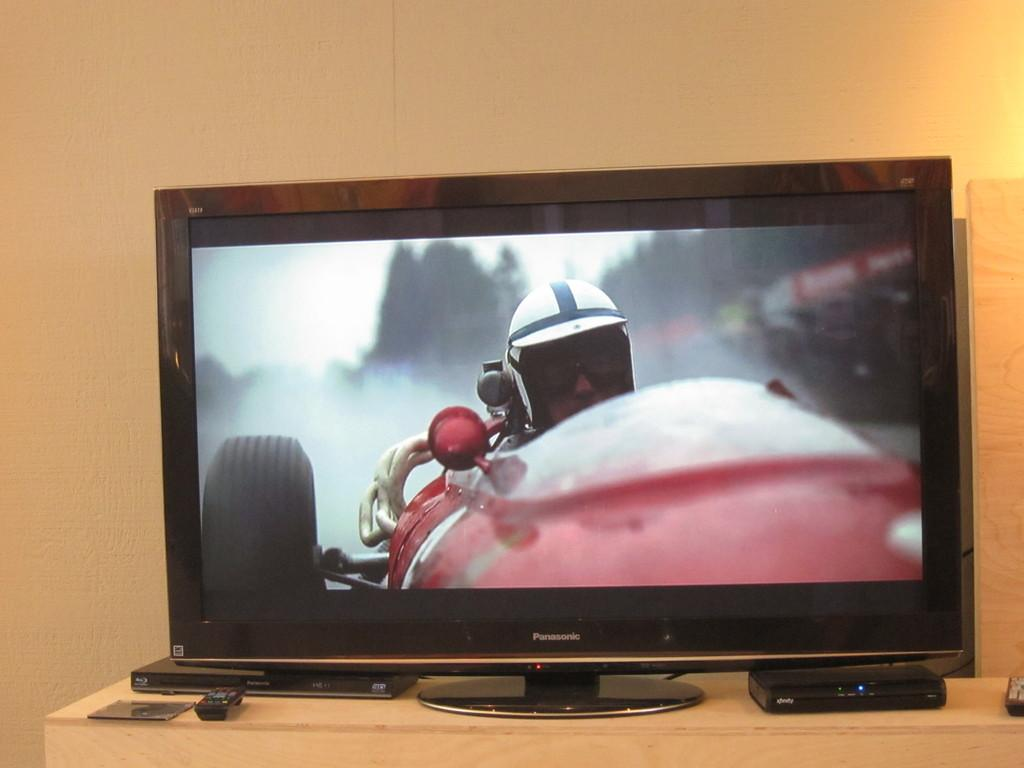Provide a one-sentence caption for the provided image. A Panasonic monitor shows a person in a race car. 